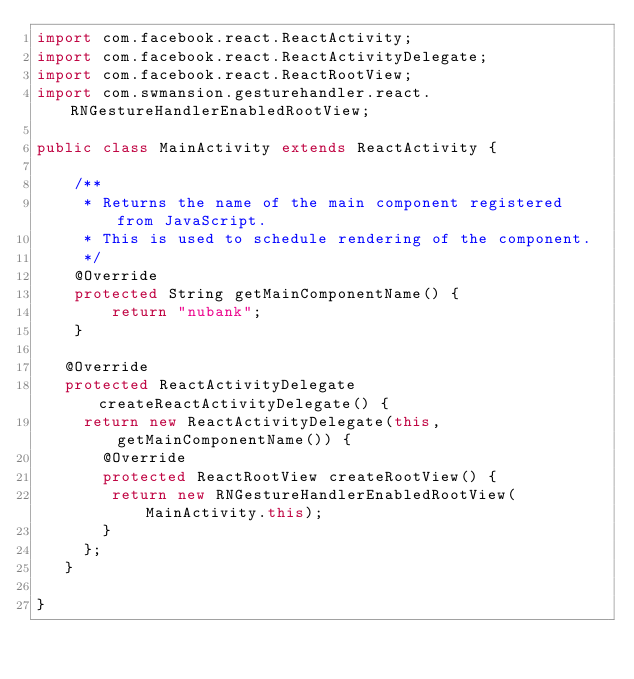<code> <loc_0><loc_0><loc_500><loc_500><_Java_>import com.facebook.react.ReactActivity;
import com.facebook.react.ReactActivityDelegate;
import com.facebook.react.ReactRootView;
import com.swmansion.gesturehandler.react.RNGestureHandlerEnabledRootView;

public class MainActivity extends ReactActivity {

    /**
     * Returns the name of the main component registered from JavaScript.
     * This is used to schedule rendering of the component.
     */
    @Override
    protected String getMainComponentName() {
        return "nubank";
    }

   @Override
   protected ReactActivityDelegate createReactActivityDelegate() {
     return new ReactActivityDelegate(this, getMainComponentName()) {
       @Override
       protected ReactRootView createRootView() {
        return new RNGestureHandlerEnabledRootView(MainActivity.this);
       }
     };
   }

}
</code> 